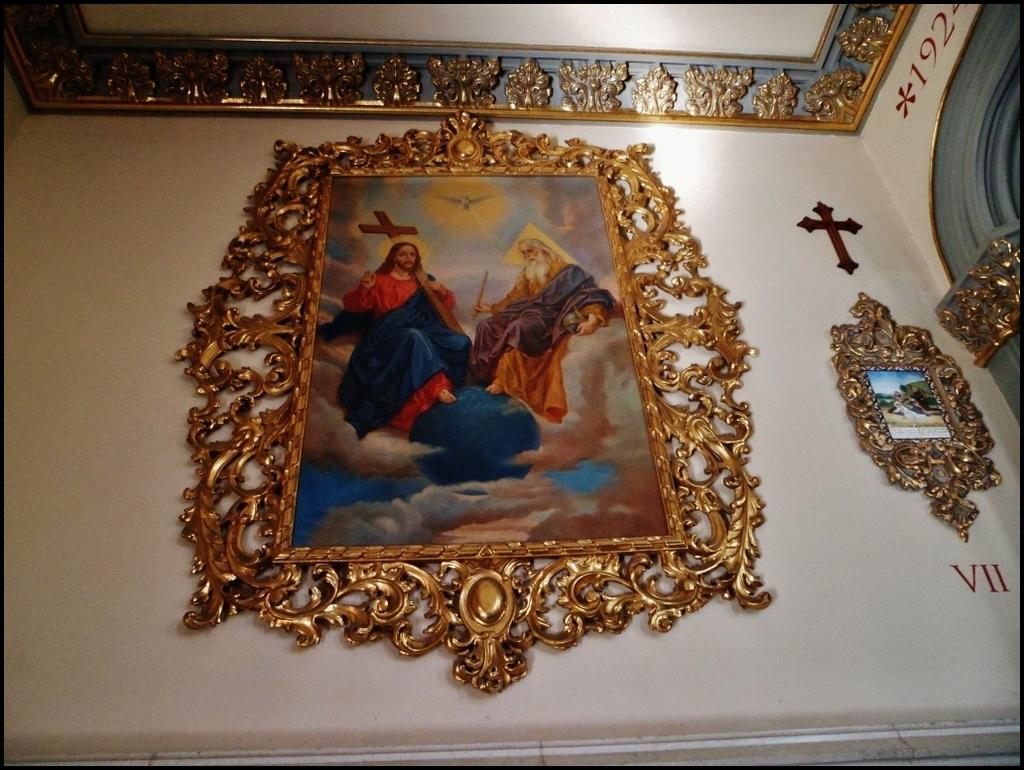What can be seen hanging on the wall in the image? There are frames on the wall in the image. What religious symbol is present on the wall? There is a Christian cross symbol on the wall. Are there any words or phrases on the wall? Yes, there is text on the wall. What type of objects are visible at the top of the image? Metal objects are visible at the top of the image. Are there any plantations visible in the image? There are no plantations present in the image. 